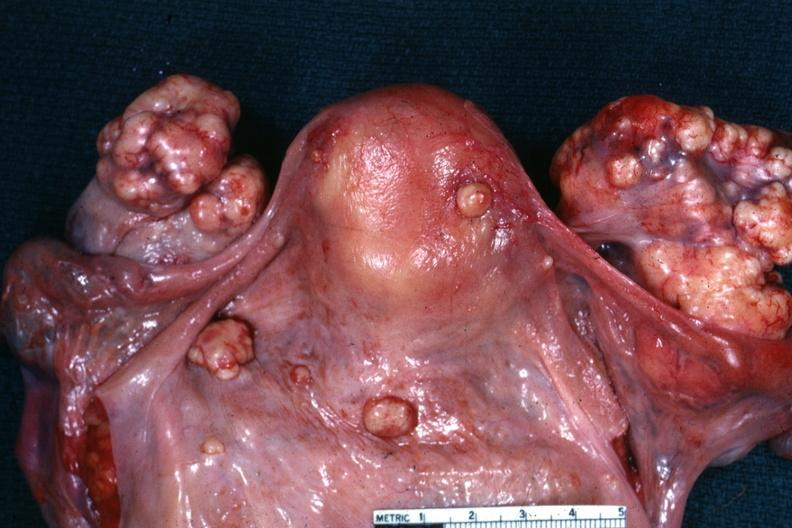where does this belong to?
Answer the question using a single word or phrase. Female reproductive system 